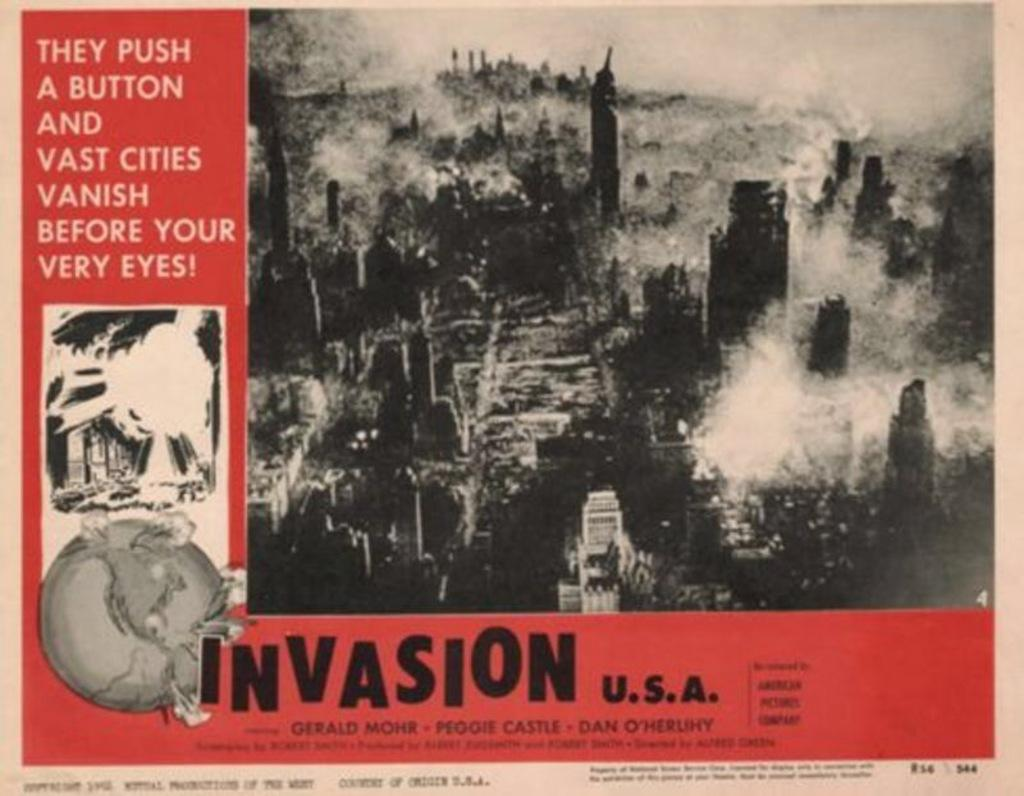What is present on the poster in the image? There is a poster in the image. What can be found on the poster besides the image? The poster contains text. What type of image is depicted on the poster? The poster contains an image of buildings. Can you tell me how many bees are buzzing around the poster in the image? There are no bees present in the image; it only features a poster with text and an image of buildings. 